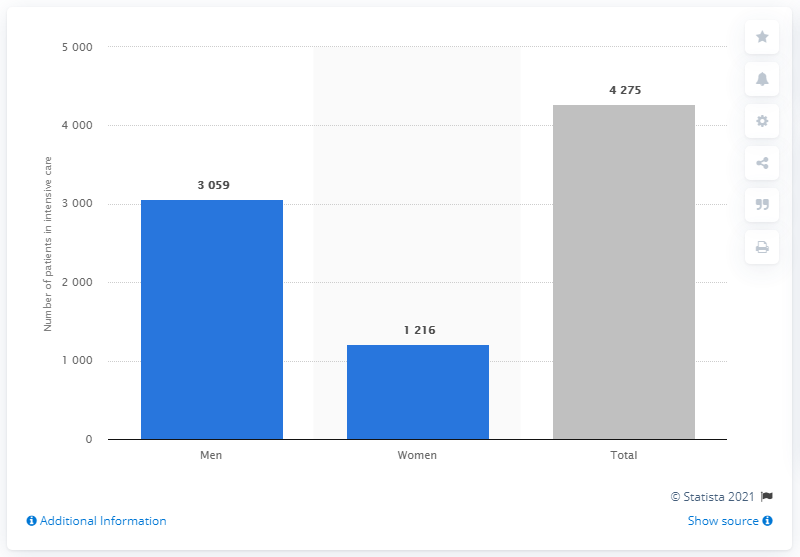Do men or women have more COVID number of of cornavirus patients in intensive care in Sweden?
 Men 